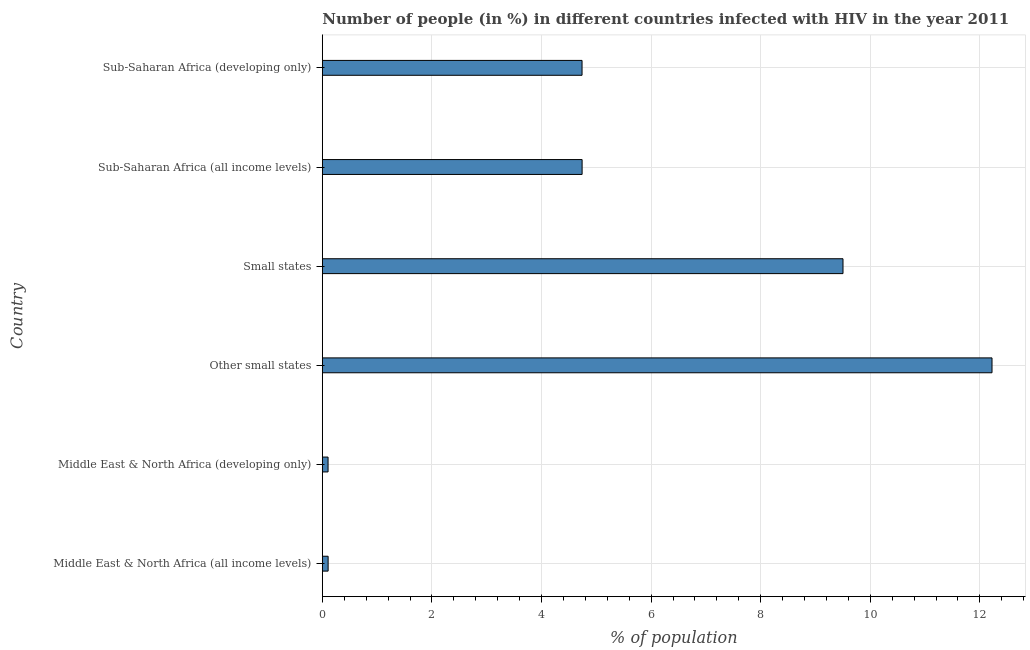Does the graph contain any zero values?
Offer a very short reply. No. What is the title of the graph?
Keep it short and to the point. Number of people (in %) in different countries infected with HIV in the year 2011. What is the label or title of the X-axis?
Provide a short and direct response. % of population. What is the number of people infected with hiv in Other small states?
Your response must be concise. 12.22. Across all countries, what is the maximum number of people infected with hiv?
Your response must be concise. 12.22. Across all countries, what is the minimum number of people infected with hiv?
Offer a very short reply. 0.1. In which country was the number of people infected with hiv maximum?
Keep it short and to the point. Other small states. In which country was the number of people infected with hiv minimum?
Provide a short and direct response. Middle East & North Africa (developing only). What is the sum of the number of people infected with hiv?
Give a very brief answer. 31.41. What is the difference between the number of people infected with hiv in Middle East & North Africa (all income levels) and Other small states?
Your answer should be very brief. -12.12. What is the average number of people infected with hiv per country?
Make the answer very short. 5.24. What is the median number of people infected with hiv?
Provide a short and direct response. 4.74. What is the ratio of the number of people infected with hiv in Middle East & North Africa (all income levels) to that in Middle East & North Africa (developing only)?
Your response must be concise. 1.01. Is the difference between the number of people infected with hiv in Small states and Sub-Saharan Africa (all income levels) greater than the difference between any two countries?
Your answer should be very brief. No. What is the difference between the highest and the second highest number of people infected with hiv?
Keep it short and to the point. 2.72. Is the sum of the number of people infected with hiv in Middle East & North Africa (all income levels) and Other small states greater than the maximum number of people infected with hiv across all countries?
Your answer should be compact. Yes. What is the difference between the highest and the lowest number of people infected with hiv?
Offer a terse response. 12.12. In how many countries, is the number of people infected with hiv greater than the average number of people infected with hiv taken over all countries?
Give a very brief answer. 2. What is the difference between two consecutive major ticks on the X-axis?
Make the answer very short. 2. What is the % of population of Middle East & North Africa (all income levels)?
Ensure brevity in your answer.  0.11. What is the % of population of Middle East & North Africa (developing only)?
Your answer should be very brief. 0.1. What is the % of population in Other small states?
Provide a short and direct response. 12.22. What is the % of population in Small states?
Your answer should be compact. 9.5. What is the % of population of Sub-Saharan Africa (all income levels)?
Provide a succinct answer. 4.74. What is the % of population in Sub-Saharan Africa (developing only)?
Keep it short and to the point. 4.74. What is the difference between the % of population in Middle East & North Africa (all income levels) and Middle East & North Africa (developing only)?
Your response must be concise. 0. What is the difference between the % of population in Middle East & North Africa (all income levels) and Other small states?
Your answer should be compact. -12.12. What is the difference between the % of population in Middle East & North Africa (all income levels) and Small states?
Offer a very short reply. -9.4. What is the difference between the % of population in Middle East & North Africa (all income levels) and Sub-Saharan Africa (all income levels)?
Your answer should be very brief. -4.64. What is the difference between the % of population in Middle East & North Africa (all income levels) and Sub-Saharan Africa (developing only)?
Offer a terse response. -4.63. What is the difference between the % of population in Middle East & North Africa (developing only) and Other small states?
Keep it short and to the point. -12.12. What is the difference between the % of population in Middle East & North Africa (developing only) and Small states?
Provide a short and direct response. -9.4. What is the difference between the % of population in Middle East & North Africa (developing only) and Sub-Saharan Africa (all income levels)?
Provide a short and direct response. -4.64. What is the difference between the % of population in Middle East & North Africa (developing only) and Sub-Saharan Africa (developing only)?
Ensure brevity in your answer.  -4.64. What is the difference between the % of population in Other small states and Small states?
Keep it short and to the point. 2.72. What is the difference between the % of population in Other small states and Sub-Saharan Africa (all income levels)?
Offer a very short reply. 7.48. What is the difference between the % of population in Other small states and Sub-Saharan Africa (developing only)?
Make the answer very short. 7.48. What is the difference between the % of population in Small states and Sub-Saharan Africa (all income levels)?
Provide a succinct answer. 4.76. What is the difference between the % of population in Small states and Sub-Saharan Africa (developing only)?
Your response must be concise. 4.76. What is the difference between the % of population in Sub-Saharan Africa (all income levels) and Sub-Saharan Africa (developing only)?
Offer a terse response. 0. What is the ratio of the % of population in Middle East & North Africa (all income levels) to that in Other small states?
Ensure brevity in your answer.  0.01. What is the ratio of the % of population in Middle East & North Africa (all income levels) to that in Small states?
Offer a very short reply. 0.01. What is the ratio of the % of population in Middle East & North Africa (all income levels) to that in Sub-Saharan Africa (all income levels)?
Provide a short and direct response. 0.02. What is the ratio of the % of population in Middle East & North Africa (all income levels) to that in Sub-Saharan Africa (developing only)?
Keep it short and to the point. 0.02. What is the ratio of the % of population in Middle East & North Africa (developing only) to that in Other small states?
Your response must be concise. 0.01. What is the ratio of the % of population in Middle East & North Africa (developing only) to that in Small states?
Offer a terse response. 0.01. What is the ratio of the % of population in Middle East & North Africa (developing only) to that in Sub-Saharan Africa (all income levels)?
Give a very brief answer. 0.02. What is the ratio of the % of population in Middle East & North Africa (developing only) to that in Sub-Saharan Africa (developing only)?
Ensure brevity in your answer.  0.02. What is the ratio of the % of population in Other small states to that in Small states?
Offer a terse response. 1.29. What is the ratio of the % of population in Other small states to that in Sub-Saharan Africa (all income levels)?
Offer a terse response. 2.58. What is the ratio of the % of population in Other small states to that in Sub-Saharan Africa (developing only)?
Give a very brief answer. 2.58. What is the ratio of the % of population in Small states to that in Sub-Saharan Africa (all income levels)?
Your answer should be compact. 2. What is the ratio of the % of population in Small states to that in Sub-Saharan Africa (developing only)?
Provide a short and direct response. 2. What is the ratio of the % of population in Sub-Saharan Africa (all income levels) to that in Sub-Saharan Africa (developing only)?
Provide a succinct answer. 1. 